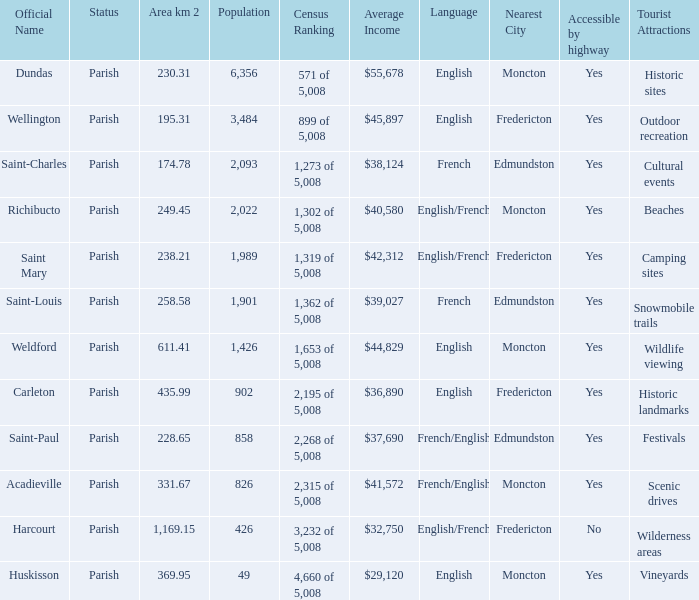For Saint-Paul parish, if it has an area of over 228.65 kilometers how many people live there? 0.0. 